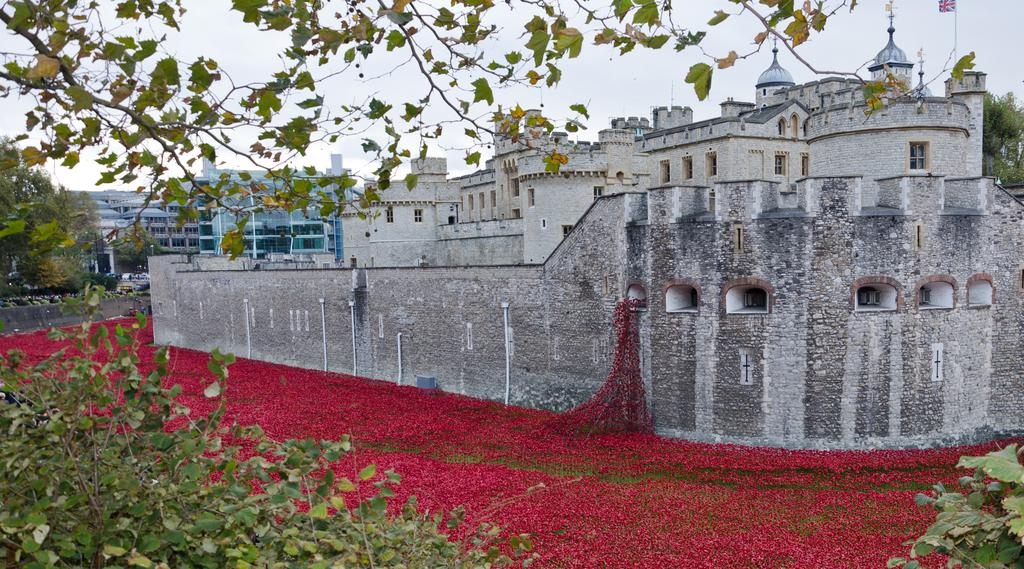What is the main subject in the center of the image? There are buildings at the center of the image. What type of vegetation can be seen on the left side of the image? There are trees on the left side of the image. What additional elements are present on the surface of the image? There are flowers on the surface of the image. What is the weight of the car in the image? There is no car present in the image. 